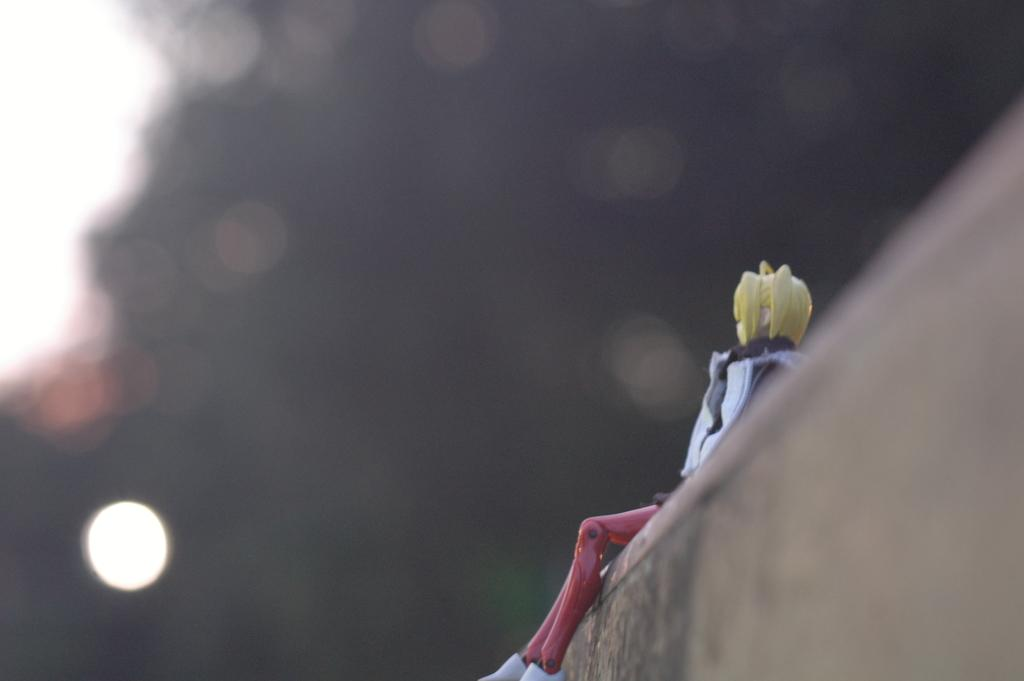What is hanging on the wall in the image? There is a doll on the wall in the image. What can be seen in the background of the image? There are lights in the background of the image. What type of border is depicted in the image? There is no border depicted in the image; it only features a doll on the wall and lights in the background. 